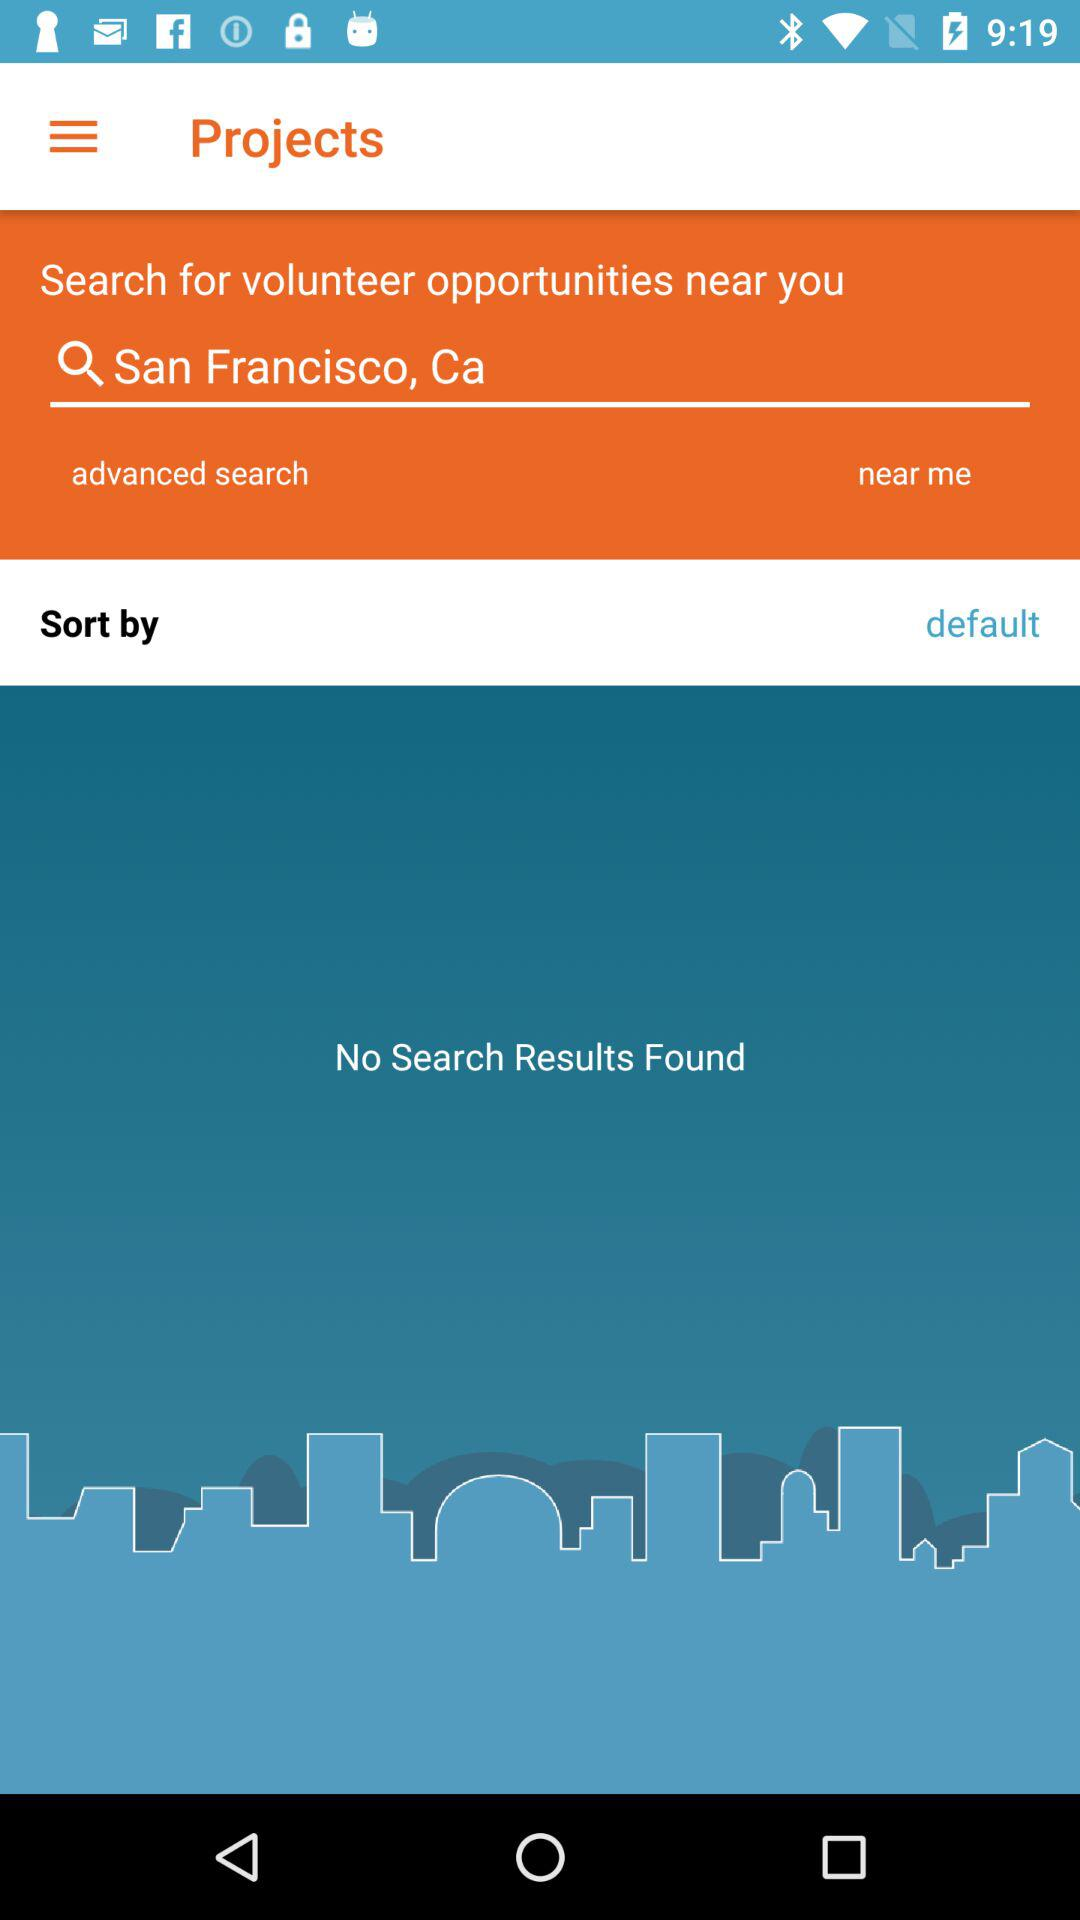What is the location's name in the search box? The location's name is "San Francisco, Ca". 